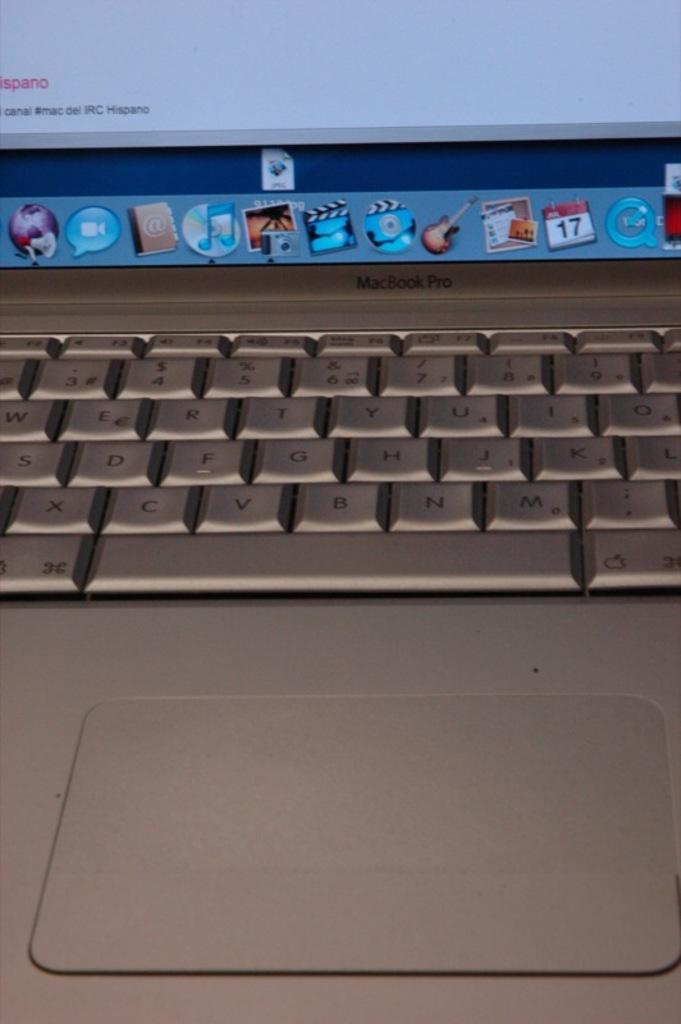What brand of computer is this?
Provide a succinct answer. Macbook pro. 